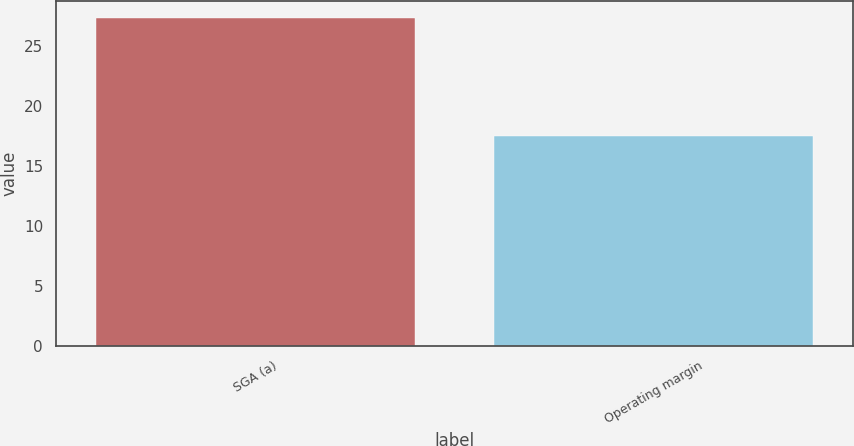Convert chart. <chart><loc_0><loc_0><loc_500><loc_500><bar_chart><fcel>SGA (a)<fcel>Operating margin<nl><fcel>27.4<fcel>17.5<nl></chart> 